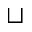<formula> <loc_0><loc_0><loc_500><loc_500>\sqcup</formula> 